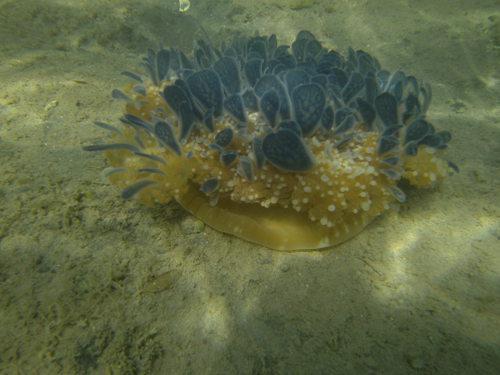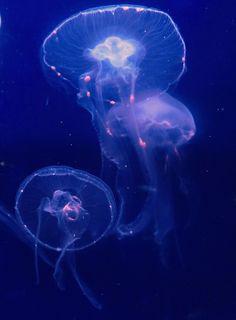The first image is the image on the left, the second image is the image on the right. Analyze the images presented: Is the assertion "The left and right image contains the same number of jellyfish." valid? Answer yes or no. No. The first image is the image on the left, the second image is the image on the right. Given the left and right images, does the statement "The left image contains a single jellyfish, which has an upright mushroom-shaped cap that trails stringy and ruffly tentacles beneath it." hold true? Answer yes or no. No. 